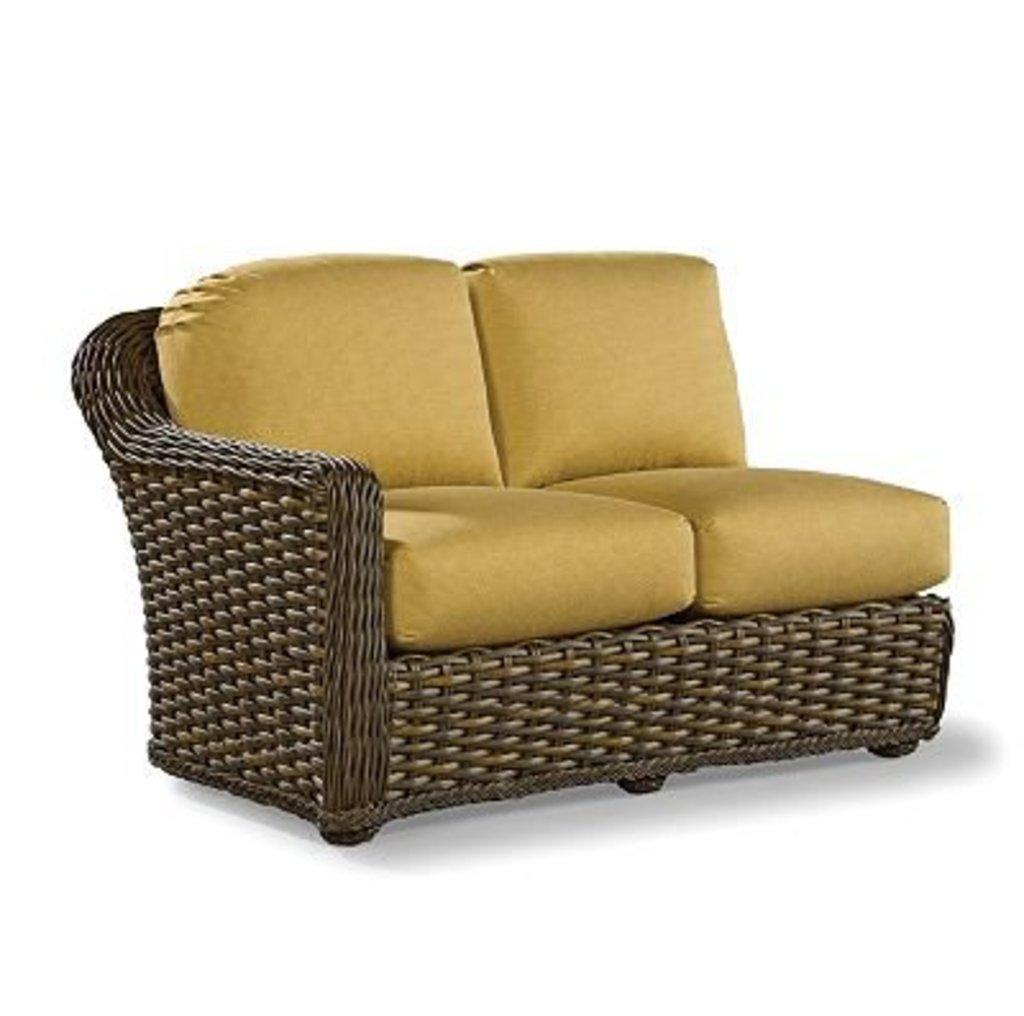What type of furniture is present in the image? There is a sofa in the image. What color is the background of the image? The background of the image is white. Can you see any islands in the image? There are no islands present in the image. 